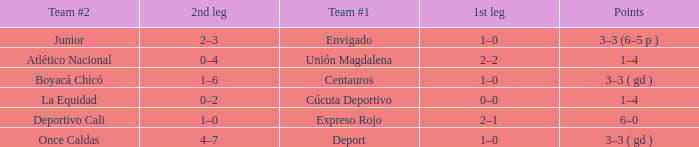What is the team #2 with Deport as team #1? Once Caldas. 